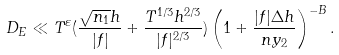<formula> <loc_0><loc_0><loc_500><loc_500>D _ { E } \ll T ^ { \varepsilon } ( \frac { \sqrt { n _ { 1 } } h } { | f | } + \frac { T ^ { 1 / 3 } h ^ { 2 / 3 } } { | f | ^ { 2 / 3 } } ) \left ( 1 + \frac { | f | \Delta h } { n y _ { 2 } } \right ) ^ { - B } .</formula> 